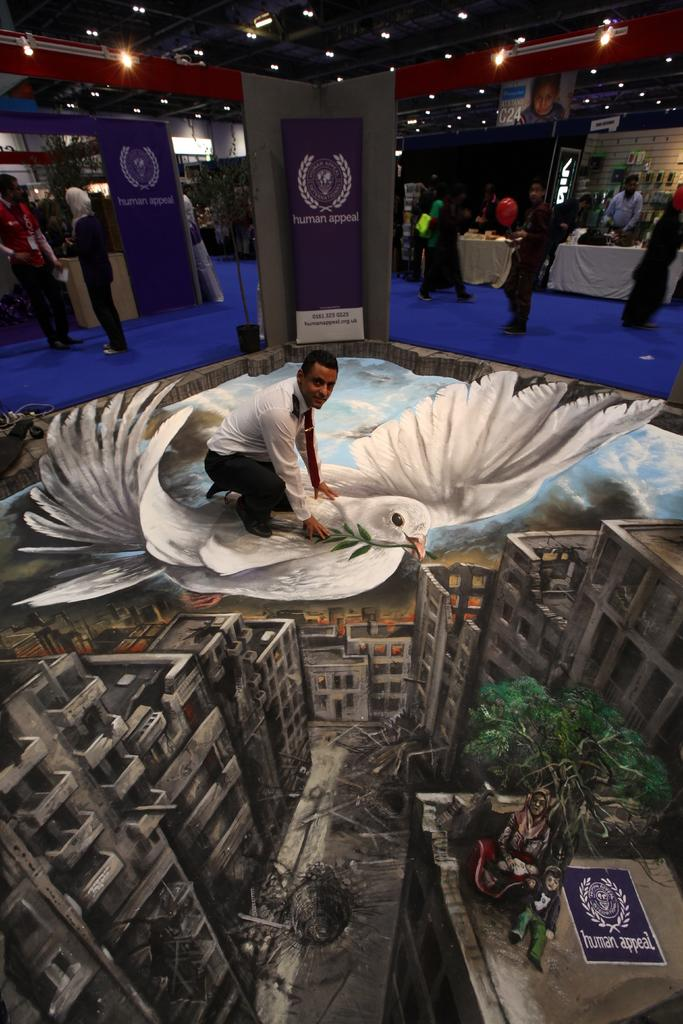What is the main subject of the image? There is a person painting in the center of the image. What can be seen in the background of the image? There are many people in the background of the image. What is located at the top of the image? There is a ceiling with lights at the top of the image. How many trucks are parked in the cemetery in the image? There is no cemetery or trucks present in the image; it features a person painting with people in the background and a ceiling with lights. 